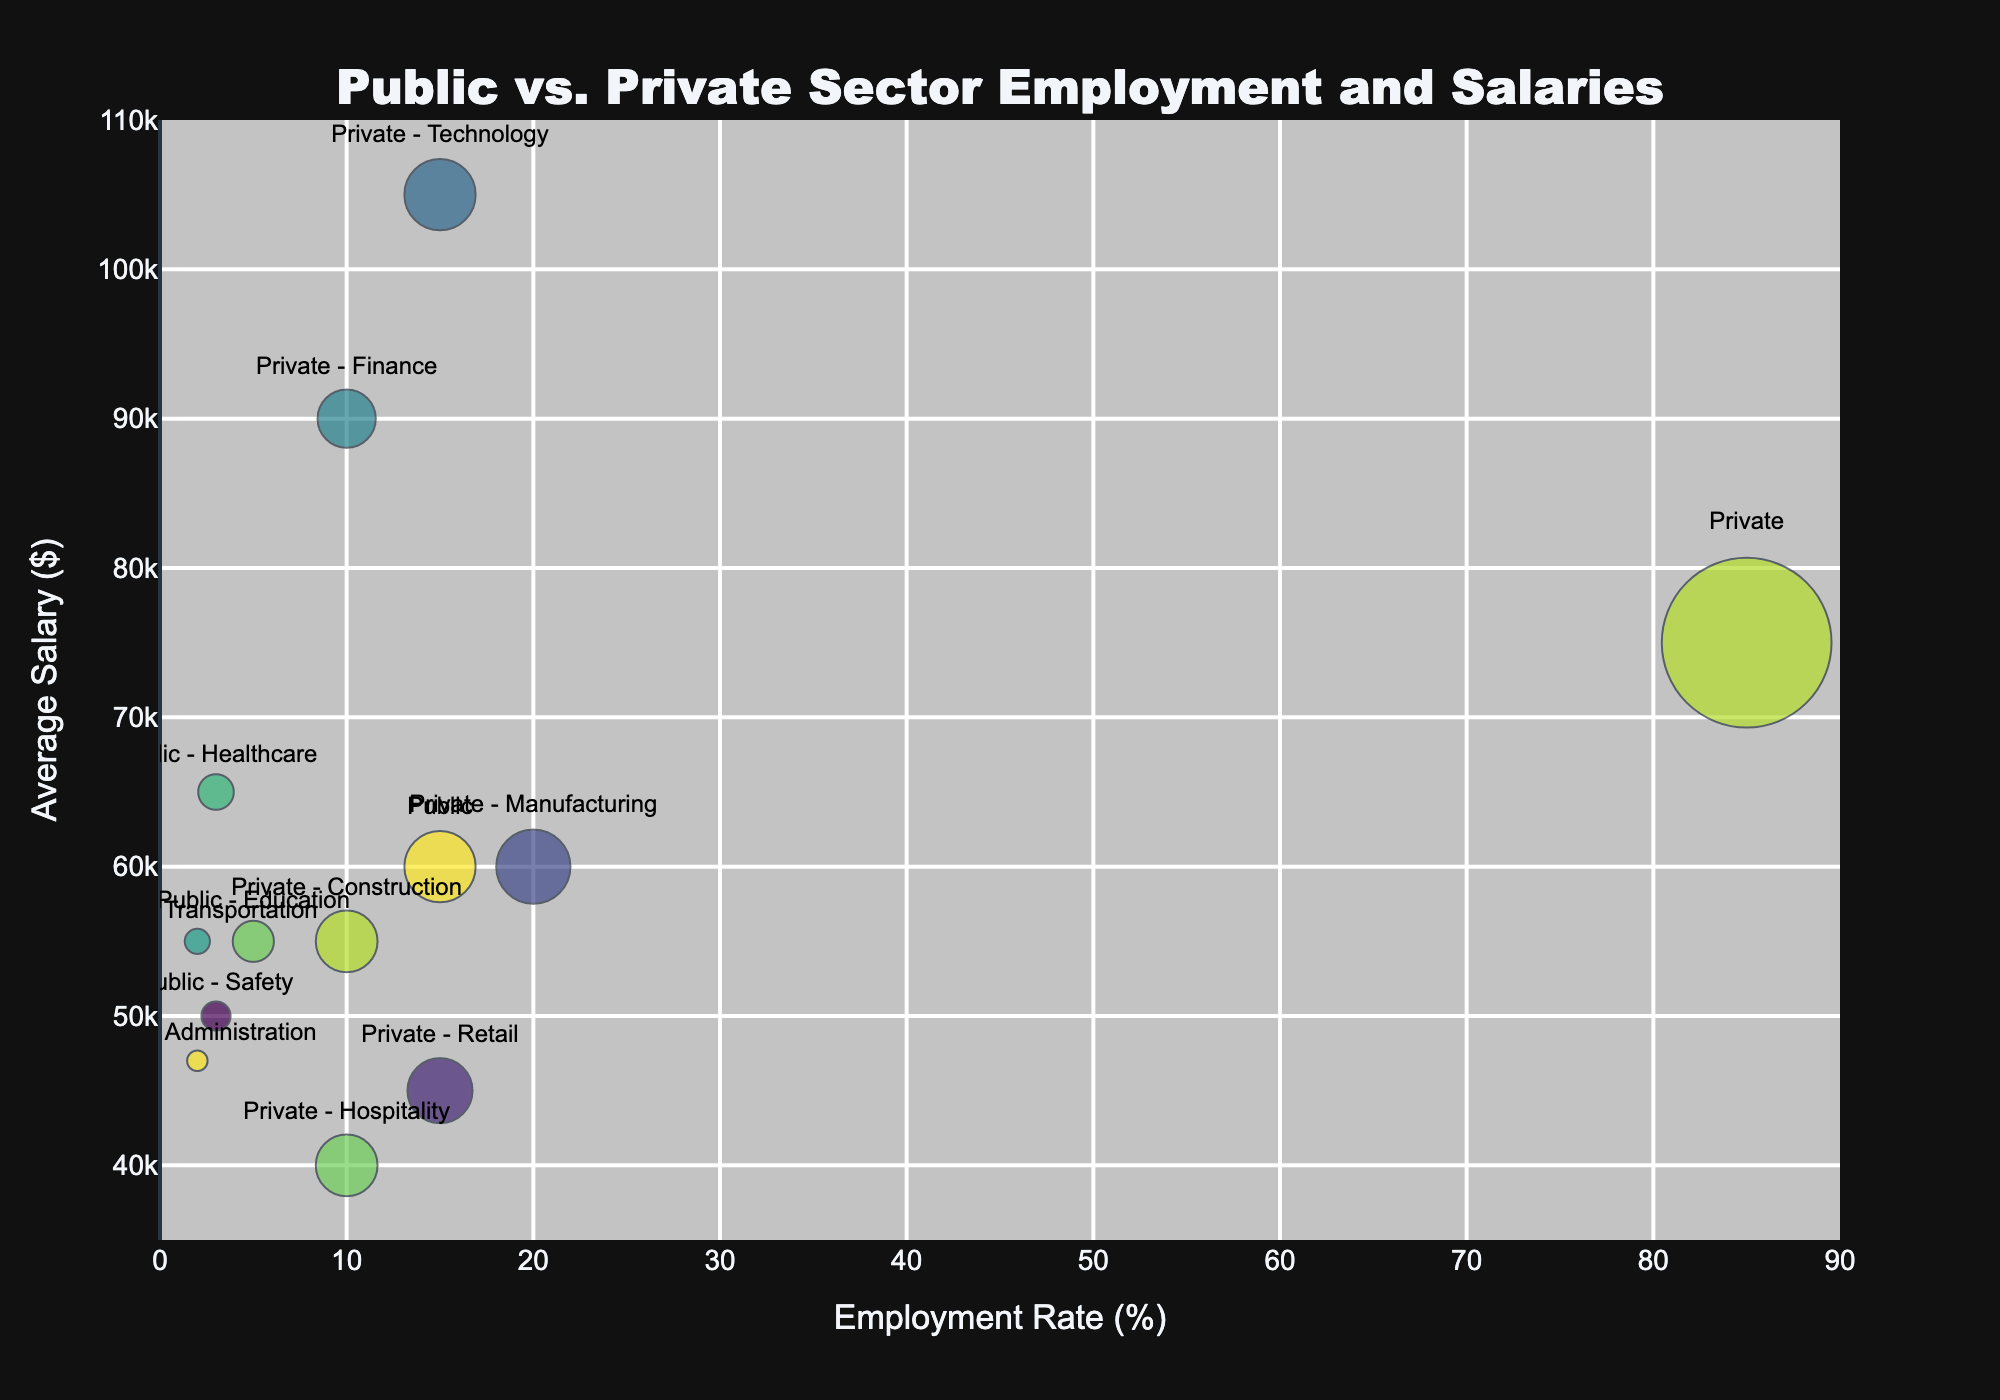How many bubbles represent the public sector? The bubbles represent different sectors of public and private employment. By identifying the ones labeled with "Public" in their names (Public, Public - Education, Public - Healthcare, Public - Transportation, Public - Safety, Public - Administration), we count the number of these bubbles.
Answer: 6 How does the average salary compare between the public sector and the private sector? Locate the bubbles labeled "Public" and "Private" sectors and compare their positions on the y-axis (Average Salary). The public sector bubble is around $60,000 and the private sector bubble is around $75,000.
Answer: Private sector has a higher average salary Which sector has the highest employment rate? Examine the x-axis (Employment Rate %) and find the bubble that is farthest to the right. The bubble representing the "Private" sector is located at 85%, which is the highest.
Answer: Private sector How many employees are in the Public - Healthcare sector? The bubble for "Public - Healthcare" has a size that represents the Bubble Size (Number of Employees). By referring to the size information, we see that it represents 300,000 employees.
Answer: 300,000 What is the difference in average salary between Private - Finance and Private - Hospitality sectors? Locate the "Private - Finance" and "Private - Hospitality" bubbles and compare their y-axis values. Private - Finance is at $90,000 and Private - Hospitality is at $40,000. Subtract to find the difference: $90,000 - $40,000 = $50,000.
Answer: $50,000 Which sector has the lowest average salary? Check the y-axis for the bubble at the lowest position. The bubble labeled "Private - Hospitality" is at $40,000, which is the lowest among all sectors.
Answer: Private - Hospitality Compare the employment rates and average salaries of Private - Technology and Public - Education sectors. Private - Technology has an employment rate of 15% and an average salary of $105,000, while Public - Education has an employment rate of 5% and an average salary of $55,000. Private - Technology has higher values in both metrics.
Answer: Private - Technology has higher employment rate and average salary Which public sector subcategory has the highest average salary? Focus on bubbles with "Public" in their labels and compare their y-axis values. "Public - Healthcare" has the highest average salary among the public subcategories, at $65,000.
Answer: Public - Healthcare Calculate the total number of public sector employees represented in the chart. Sum the bubble sizes of all public sector categories: Public (1,200,000), Public - Education (400,000), Public - Healthcare (300,000), Public - Transportation (150,000), Public - Safety (200,000), Public - Administration (100,000). Total: 1,200,000 + 400,000 + 300,000 + 150,000 + 200,000 + 100,000 = 2,350,000.
Answer: 2,350,000 Compare the average salaries of Private - Construction and Public - Transportation. Look at the y-axis values for "Private - Construction" and "Public - Transportation." Private - Construction has an average salary of $55,000, and Public - Transportation is also at $55,000. Both have the same average salary.
Answer: Same 